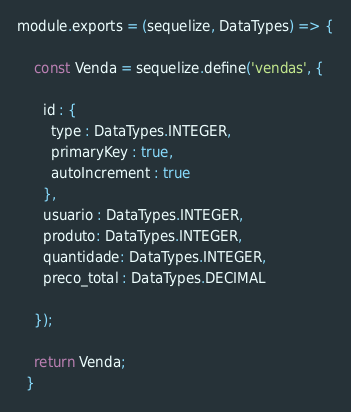Convert code to text. <code><loc_0><loc_0><loc_500><loc_500><_JavaScript_>module.exports = (sequelize, DataTypes) => {

    const Venda = sequelize.define('vendas', {

      id : {
        type : DataTypes.INTEGER,
        primaryKey : true,
        autoIncrement : true
      },  
      usuario : DataTypes.INTEGER,      
      produto: DataTypes.INTEGER,
      quantidade: DataTypes.INTEGER,
      preco_total : DataTypes.DECIMAL
      
    });
  
    return Venda;
  }
</code> 